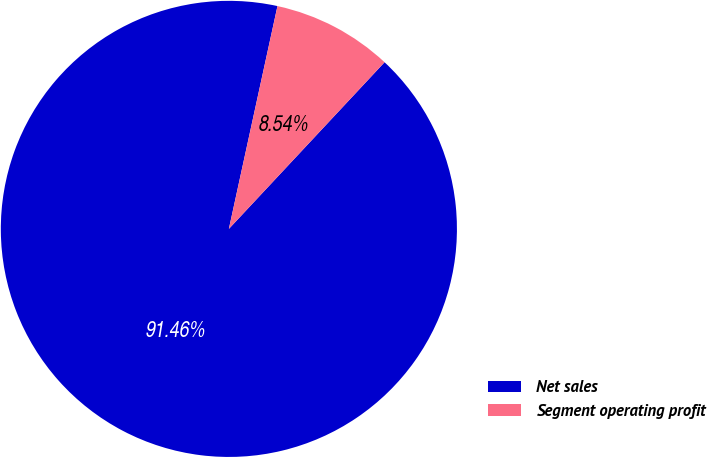<chart> <loc_0><loc_0><loc_500><loc_500><pie_chart><fcel>Net sales<fcel>Segment operating profit<nl><fcel>91.46%<fcel>8.54%<nl></chart> 